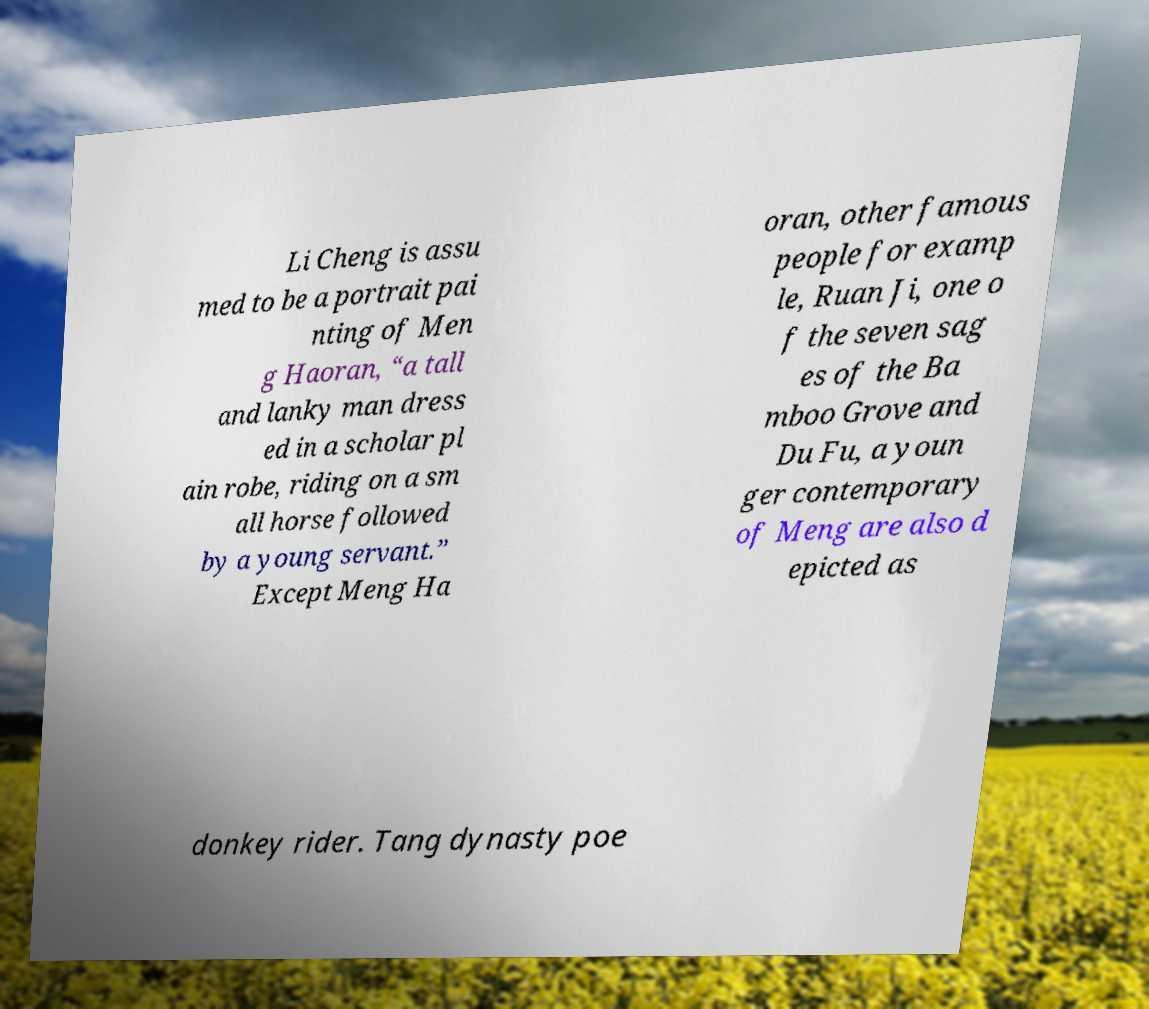Could you assist in decoding the text presented in this image and type it out clearly? Li Cheng is assu med to be a portrait pai nting of Men g Haoran, “a tall and lanky man dress ed in a scholar pl ain robe, riding on a sm all horse followed by a young servant.” Except Meng Ha oran, other famous people for examp le, Ruan Ji, one o f the seven sag es of the Ba mboo Grove and Du Fu, a youn ger contemporary of Meng are also d epicted as donkey rider. Tang dynasty poe 